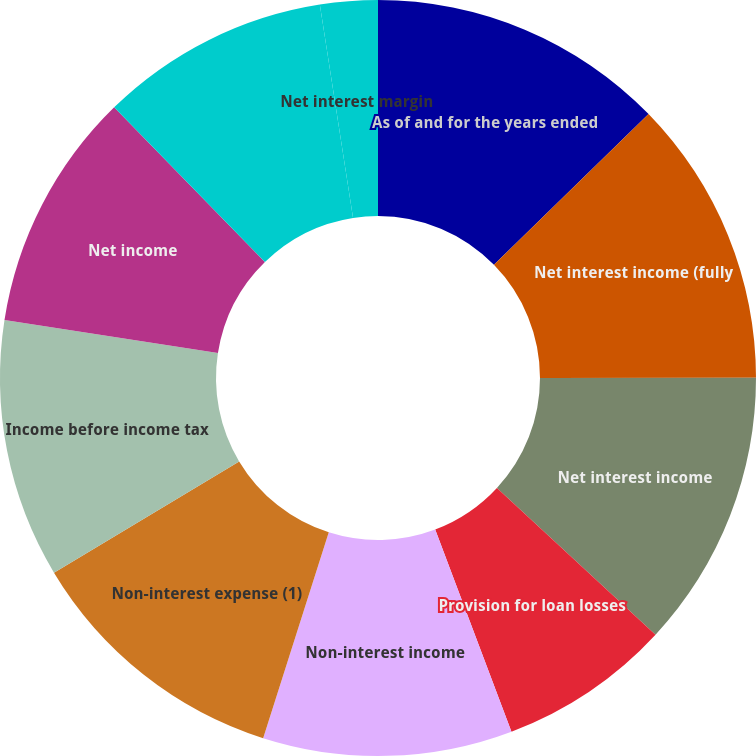<chart> <loc_0><loc_0><loc_500><loc_500><pie_chart><fcel>As of and for the years ended<fcel>Net interest income (fully<fcel>Net interest income<fcel>Provision for loan losses<fcel>Non-interest income<fcel>Non-interest expense (1)<fcel>Income before income tax<fcel>Net income<fcel>Net income available to common<fcel>Net interest margin<nl><fcel>12.7%<fcel>12.3%<fcel>11.89%<fcel>7.38%<fcel>10.66%<fcel>11.48%<fcel>11.07%<fcel>10.25%<fcel>9.84%<fcel>2.46%<nl></chart> 